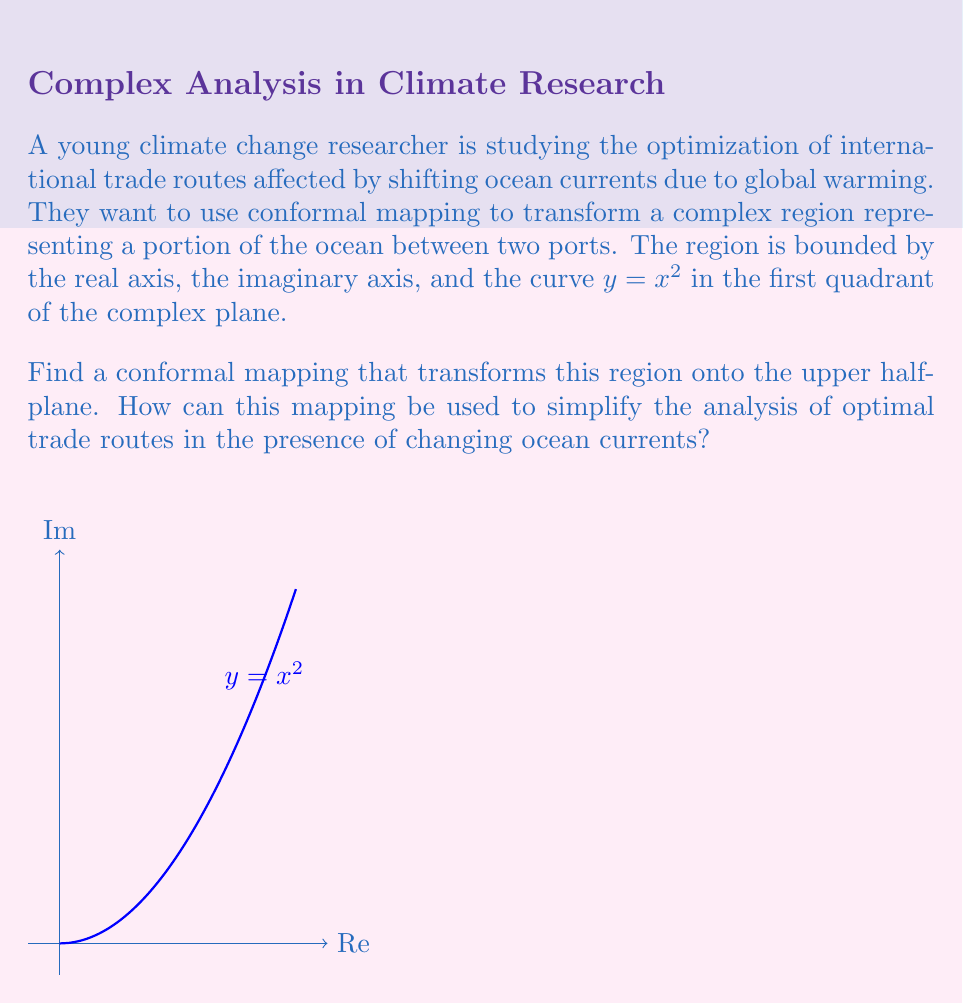Show me your answer to this math problem. To solve this problem, we'll follow these steps:

1) The given region is bounded by the real axis, imaginary axis, and the curve $y = x^2$. This shape resembles a quarter of a parabola in the first quadrant.

2) To map this region to the upper half-plane, we can use the square root function. The square root function has the property of "unwrapping" the region around the origin.

3) The conformal mapping we'll use is:

   $$w = f(z) = \sqrt{z}$$

4) This mapping has the following effects:
   - It maps the positive real axis to itself.
   - It maps the positive imaginary axis to the negative real axis.
   - It maps the curve $y = x^2$ to the positive imaginary axis.

5) To verify this last point, consider a point $z = x + ix^2$ on the curve. Applying our mapping:

   $$w = \sqrt{x + ix^2} = \sqrt{x(1+ix)} = \sqrt{x}\sqrt{1+ix}$$

   When $x$ is small, $\sqrt{1+ix} \approx 1 + \frac{1}{2}ix$, so $w \approx \sqrt{x}(1 + \frac{1}{2}ix) = \sqrt{x} + \frac{1}{2}ix\sqrt{x}$

   This shows that points near the origin on the curve $y = x^2$ are mapped to points slightly above the positive real axis, confirming that the curve is indeed mapped to the positive imaginary axis.

6) The inverse of this mapping is $z = w^2$, which can be used to transform problems in the original domain to potentially simpler problems in the upper half-plane.

7) In the context of trade route optimization:
   - Ocean currents and other geographic features in the original domain become transformed in the upper half-plane.
   - The straight line paths in the upper half-plane correspond to curved paths in the original domain.
   - Optimization problems (e.g., finding the path of least resistance) might become easier to solve in the transformed domain.
   - Once a solution is found in the upper half-plane, it can be mapped back to the original domain using the inverse transformation.

This conformal mapping allows the researcher to work in a simpler geometric domain (the upper half-plane) while preserving angles and local shapes, which is crucial for analyzing flow patterns and optimizing routes.
Answer: $w = \sqrt{z}$ 